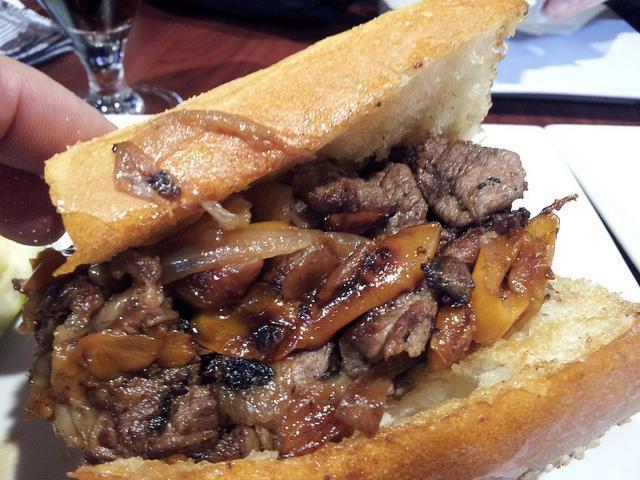How many dining tables are there?
Give a very brief answer. 2. 